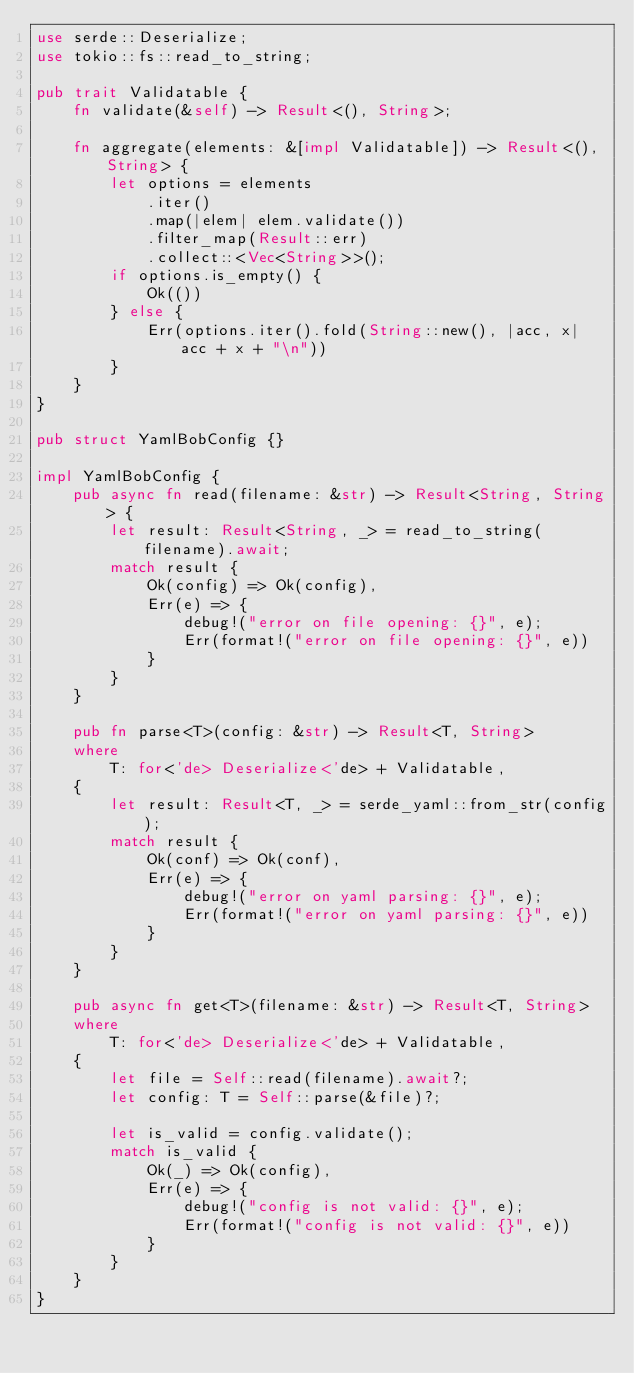<code> <loc_0><loc_0><loc_500><loc_500><_Rust_>use serde::Deserialize;
use tokio::fs::read_to_string;

pub trait Validatable {
    fn validate(&self) -> Result<(), String>;

    fn aggregate(elements: &[impl Validatable]) -> Result<(), String> {
        let options = elements
            .iter()
            .map(|elem| elem.validate())
            .filter_map(Result::err)
            .collect::<Vec<String>>();
        if options.is_empty() {
            Ok(())
        } else {
            Err(options.iter().fold(String::new(), |acc, x| acc + x + "\n"))
        }
    }
}

pub struct YamlBobConfig {}

impl YamlBobConfig {
    pub async fn read(filename: &str) -> Result<String, String> {
        let result: Result<String, _> = read_to_string(filename).await;
        match result {
            Ok(config) => Ok(config),
            Err(e) => {
                debug!("error on file opening: {}", e);
                Err(format!("error on file opening: {}", e))
            }
        }
    }

    pub fn parse<T>(config: &str) -> Result<T, String>
    where
        T: for<'de> Deserialize<'de> + Validatable,
    {
        let result: Result<T, _> = serde_yaml::from_str(config);
        match result {
            Ok(conf) => Ok(conf),
            Err(e) => {
                debug!("error on yaml parsing: {}", e);
                Err(format!("error on yaml parsing: {}", e))
            }
        }
    }

    pub async fn get<T>(filename: &str) -> Result<T, String>
    where
        T: for<'de> Deserialize<'de> + Validatable,
    {
        let file = Self::read(filename).await?;
        let config: T = Self::parse(&file)?;

        let is_valid = config.validate();
        match is_valid {
            Ok(_) => Ok(config),
            Err(e) => {
                debug!("config is not valid: {}", e);
                Err(format!("config is not valid: {}", e))
            }
        }
    }
}
</code> 